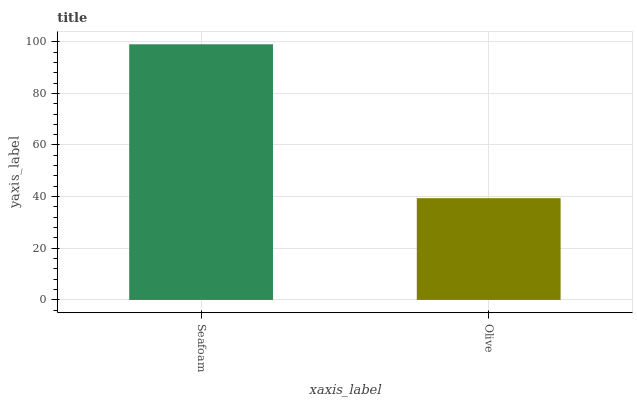Is Olive the minimum?
Answer yes or no. Yes. Is Seafoam the maximum?
Answer yes or no. Yes. Is Olive the maximum?
Answer yes or no. No. Is Seafoam greater than Olive?
Answer yes or no. Yes. Is Olive less than Seafoam?
Answer yes or no. Yes. Is Olive greater than Seafoam?
Answer yes or no. No. Is Seafoam less than Olive?
Answer yes or no. No. Is Seafoam the high median?
Answer yes or no. Yes. Is Olive the low median?
Answer yes or no. Yes. Is Olive the high median?
Answer yes or no. No. Is Seafoam the low median?
Answer yes or no. No. 